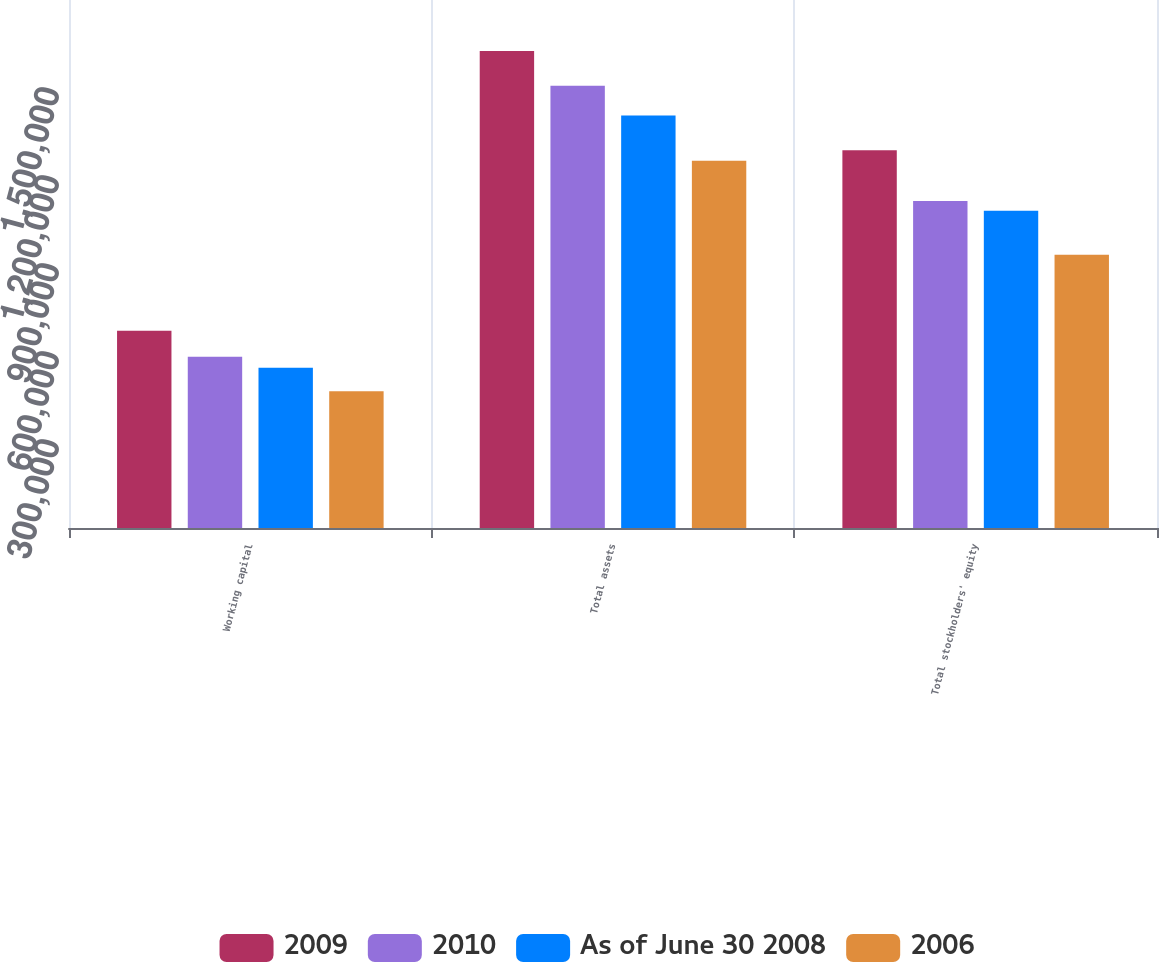Convert chart to OTSL. <chart><loc_0><loc_0><loc_500><loc_500><stacked_bar_chart><ecel><fcel>Working capital<fcel>Total assets<fcel>Total stockholders' equity<nl><fcel>2009<fcel>672669<fcel>1.6264e+06<fcel>1.28754e+06<nl><fcel>2010<fcel>584184<fcel>1.50797e+06<fcel>1.11519e+06<nl><fcel>As of June 30 2008<fcel>546647<fcel>1.406e+06<fcel>1.08178e+06<nl><fcel>2006<fcel>466396<fcel>1.25204e+06<fcel>931222<nl></chart> 